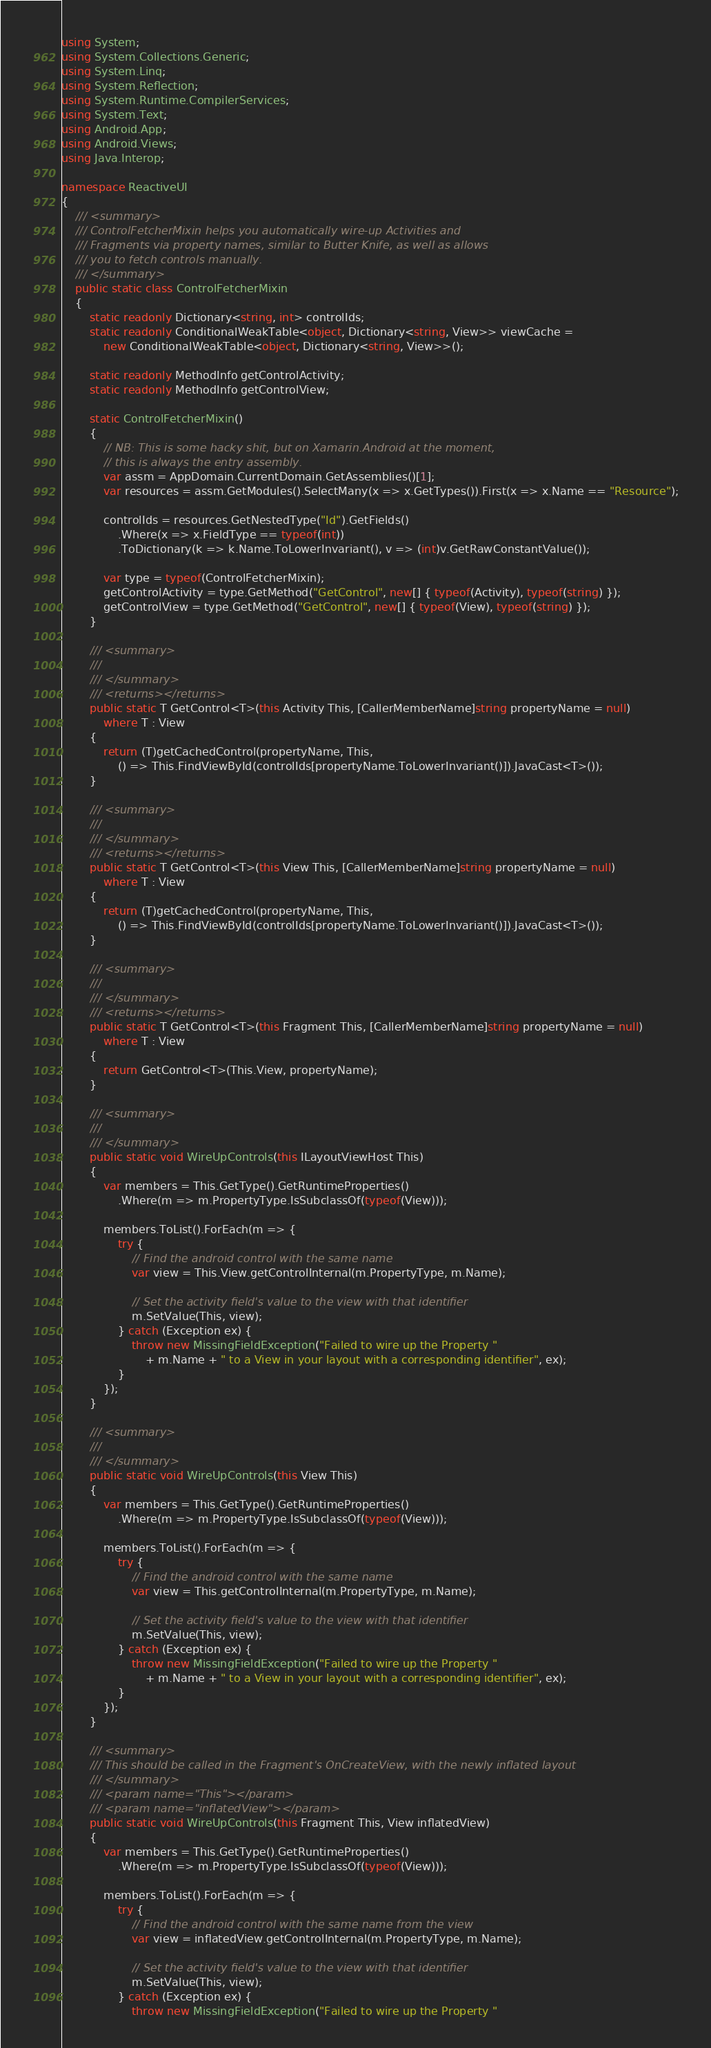Convert code to text. <code><loc_0><loc_0><loc_500><loc_500><_C#_>using System;
using System.Collections.Generic;
using System.Linq;
using System.Reflection;
using System.Runtime.CompilerServices;
using System.Text;
using Android.App;
using Android.Views;
using Java.Interop;

namespace ReactiveUI
{
    /// <summary>
    /// ControlFetcherMixin helps you automatically wire-up Activities and
    /// Fragments via property names, similar to Butter Knife, as well as allows
    /// you to fetch controls manually.
    /// </summary>
    public static class ControlFetcherMixin
    {
        static readonly Dictionary<string, int> controlIds;
        static readonly ConditionalWeakTable<object, Dictionary<string, View>> viewCache =
            new ConditionalWeakTable<object, Dictionary<string, View>>();

        static readonly MethodInfo getControlActivity;
        static readonly MethodInfo getControlView;

        static ControlFetcherMixin()
        {
            // NB: This is some hacky shit, but on Xamarin.Android at the moment,
            // this is always the entry assembly.
            var assm = AppDomain.CurrentDomain.GetAssemblies()[1];
            var resources = assm.GetModules().SelectMany(x => x.GetTypes()).First(x => x.Name == "Resource");

            controlIds = resources.GetNestedType("Id").GetFields()
                .Where(x => x.FieldType == typeof(int))
                .ToDictionary(k => k.Name.ToLowerInvariant(), v => (int)v.GetRawConstantValue());

            var type = typeof(ControlFetcherMixin);
            getControlActivity = type.GetMethod("GetControl", new[] { typeof(Activity), typeof(string) });
            getControlView = type.GetMethod("GetControl", new[] { typeof(View), typeof(string) });
        }

        /// <summary>
        ///
        /// </summary>
        /// <returns></returns>
        public static T GetControl<T>(this Activity This, [CallerMemberName]string propertyName = null)
            where T : View
        {
            return (T)getCachedControl(propertyName, This,
                () => This.FindViewById(controlIds[propertyName.ToLowerInvariant()]).JavaCast<T>());
        }

        /// <summary>
        ///
        /// </summary>
        /// <returns></returns>
        public static T GetControl<T>(this View This, [CallerMemberName]string propertyName = null)
            where T : View
        {
            return (T)getCachedControl(propertyName, This,
                () => This.FindViewById(controlIds[propertyName.ToLowerInvariant()]).JavaCast<T>());
        }

        /// <summary>
        ///
        /// </summary>
        /// <returns></returns>
        public static T GetControl<T>(this Fragment This, [CallerMemberName]string propertyName = null)
            where T : View
        {
            return GetControl<T>(This.View, propertyName);
        }

        /// <summary>
        ///
        /// </summary>
        public static void WireUpControls(this ILayoutViewHost This)
        {
            var members = This.GetType().GetRuntimeProperties()
                .Where(m => m.PropertyType.IsSubclassOf(typeof(View)));

            members.ToList().ForEach(m => {
                try {
                    // Find the android control with the same name
                    var view = This.View.getControlInternal(m.PropertyType, m.Name);

                    // Set the activity field's value to the view with that identifier
                    m.SetValue(This, view);
                } catch (Exception ex) {
                    throw new MissingFieldException("Failed to wire up the Property "
                        + m.Name + " to a View in your layout with a corresponding identifier", ex);
                }
            });
        }

        /// <summary>
        ///
        /// </summary>
        public static void WireUpControls(this View This)
        {
            var members = This.GetType().GetRuntimeProperties()
                .Where(m => m.PropertyType.IsSubclassOf(typeof(View)));

            members.ToList().ForEach(m => {
                try {
                    // Find the android control with the same name
                    var view = This.getControlInternal(m.PropertyType, m.Name);

                    // Set the activity field's value to the view with that identifier
                    m.SetValue(This, view);
                } catch (Exception ex) {
                    throw new MissingFieldException("Failed to wire up the Property "
                        + m.Name + " to a View in your layout with a corresponding identifier", ex);
                }
            });
        }

        /// <summary>
        /// This should be called in the Fragment's OnCreateView, with the newly inflated layout
        /// </summary>
        /// <param name="This"></param>
        /// <param name="inflatedView"></param>
        public static void WireUpControls(this Fragment This, View inflatedView)
        {
            var members = This.GetType().GetRuntimeProperties()
                .Where(m => m.PropertyType.IsSubclassOf(typeof(View)));

            members.ToList().ForEach(m => {
                try {
                    // Find the android control with the same name from the view
                    var view = inflatedView.getControlInternal(m.PropertyType, m.Name);

                    // Set the activity field's value to the view with that identifier
                    m.SetValue(This, view);
                } catch (Exception ex) {
                    throw new MissingFieldException("Failed to wire up the Property "</code> 